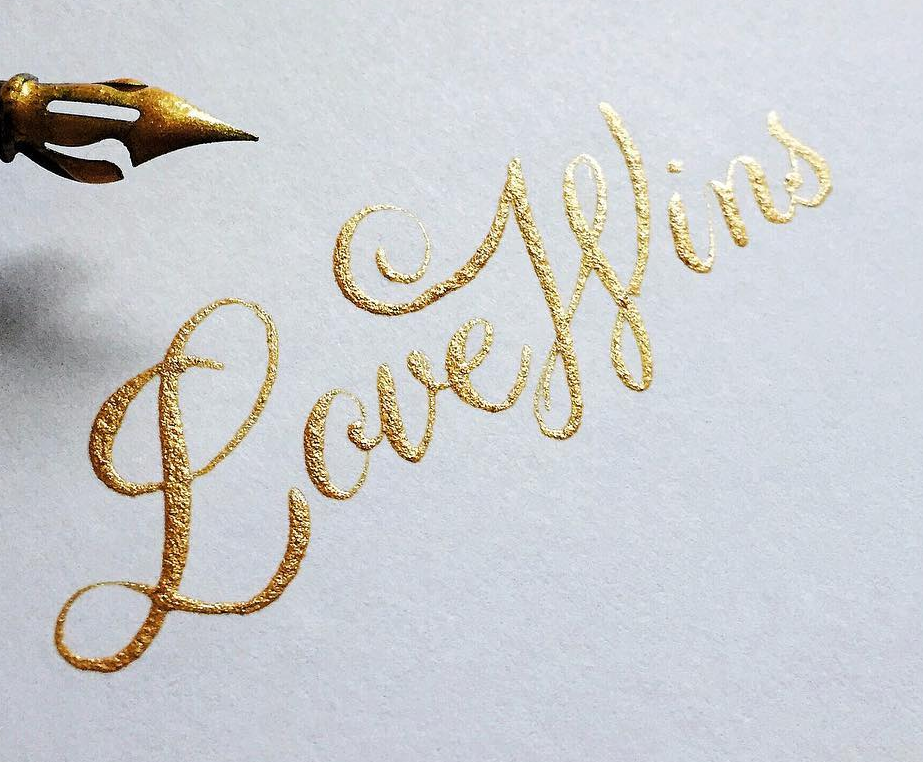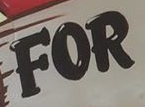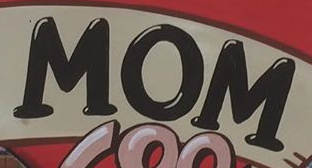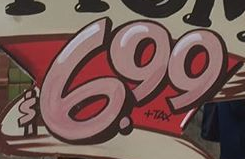Transcribe the words shown in these images in order, separated by a semicolon. LoveWins; FOR; MOM; $6.99 